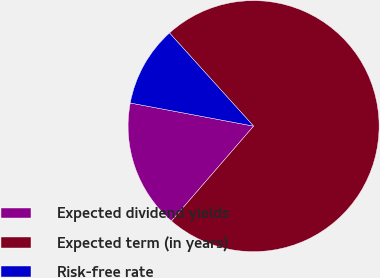Convert chart to OTSL. <chart><loc_0><loc_0><loc_500><loc_500><pie_chart><fcel>Expected dividend yields<fcel>Expected term (in years)<fcel>Risk-free rate<nl><fcel>16.6%<fcel>73.04%<fcel>10.36%<nl></chart> 